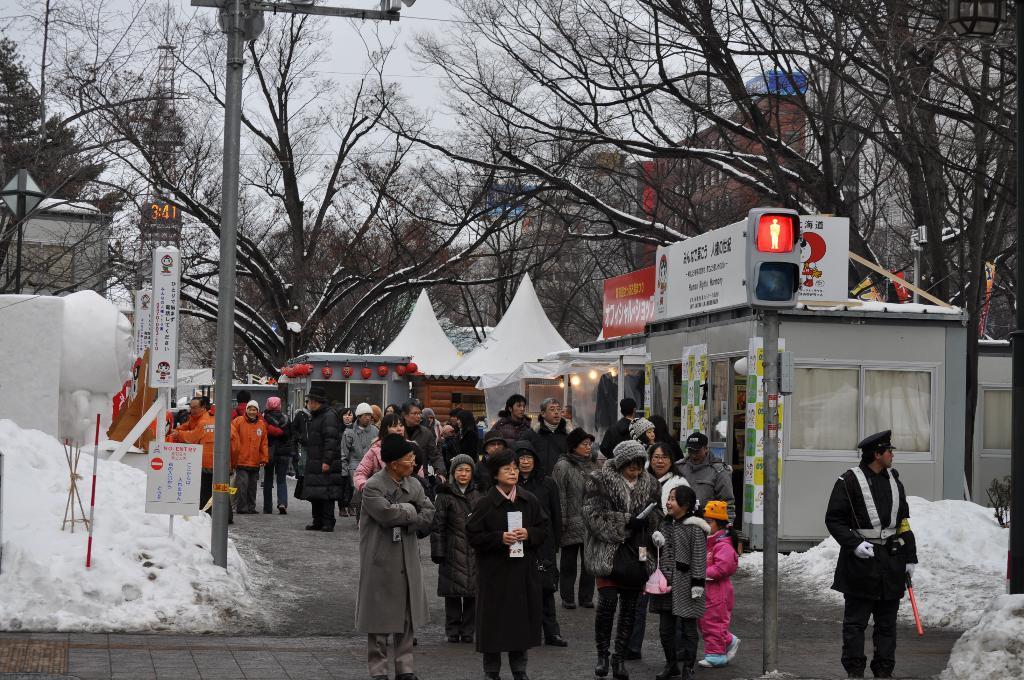Describe this image in one or two sentences. We can see group of people and we can see traffic signal on pole,boards and snow. Background we can see trees,buildings and sky. 